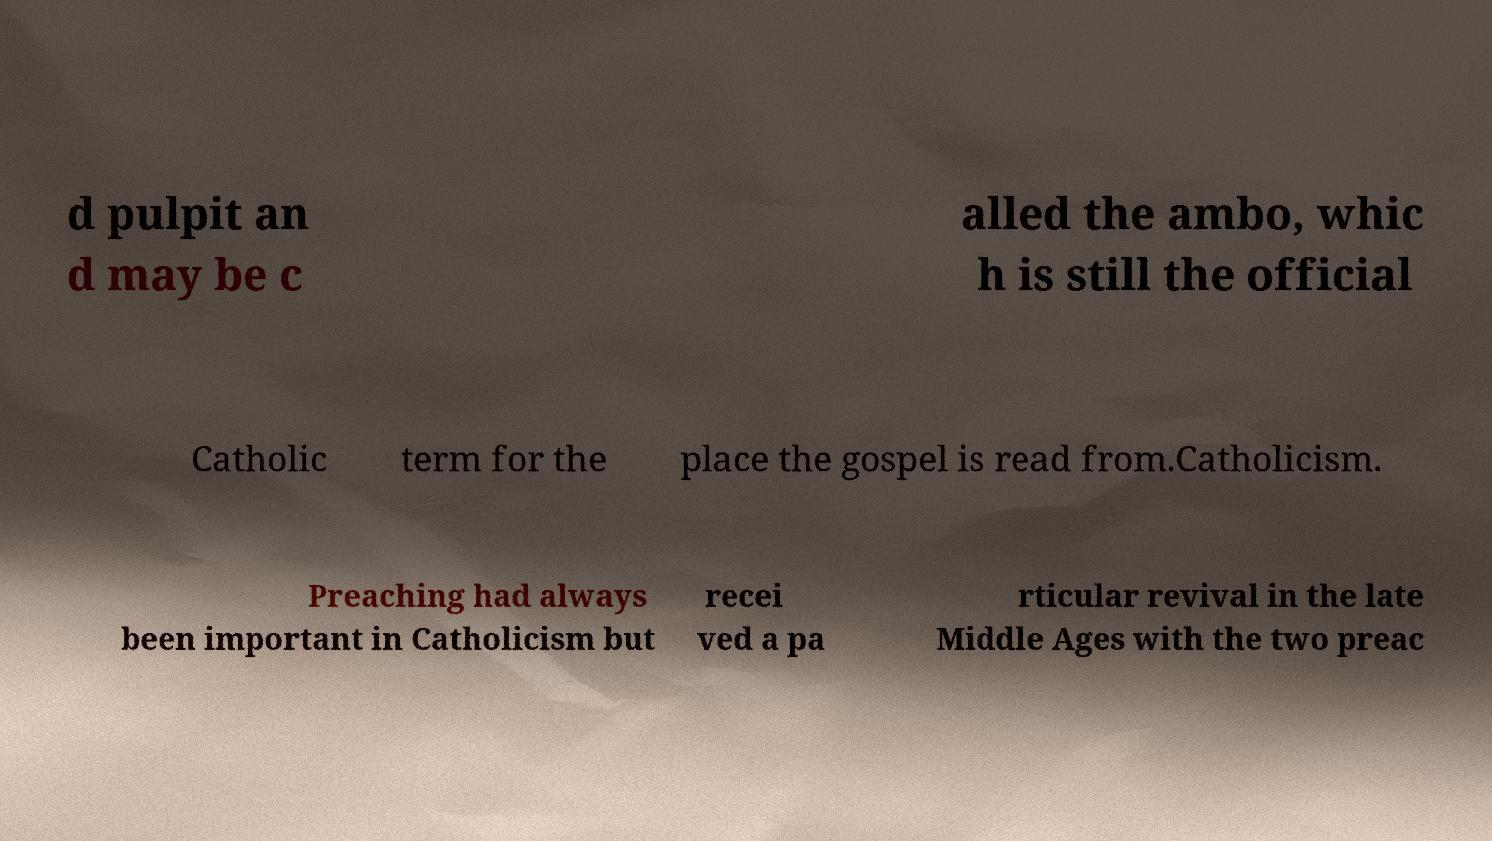Could you assist in decoding the text presented in this image and type it out clearly? d pulpit an d may be c alled the ambo, whic h is still the official Catholic term for the place the gospel is read from.Catholicism. Preaching had always been important in Catholicism but recei ved a pa rticular revival in the late Middle Ages with the two preac 